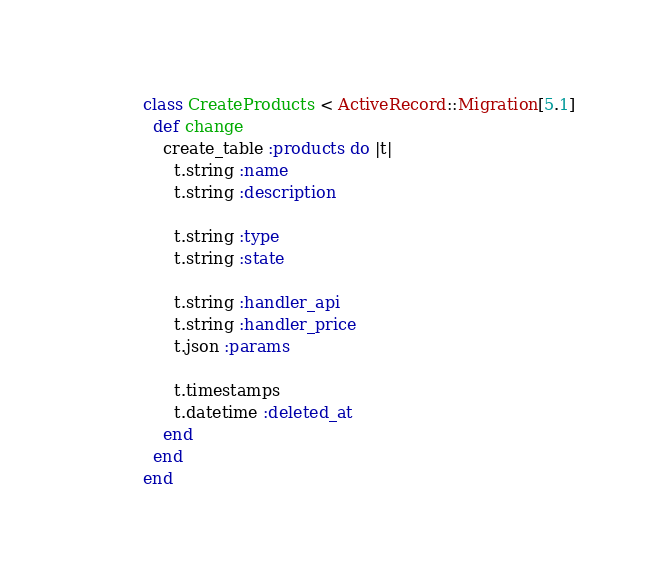<code> <loc_0><loc_0><loc_500><loc_500><_Ruby_>class CreateProducts < ActiveRecord::Migration[5.1]
  def change
    create_table :products do |t|
      t.string :name
      t.string :description

      t.string :type
      t.string :state

      t.string :handler_api
      t.string :handler_price
      t.json :params

      t.timestamps
      t.datetime :deleted_at
    end
  end
end
</code> 